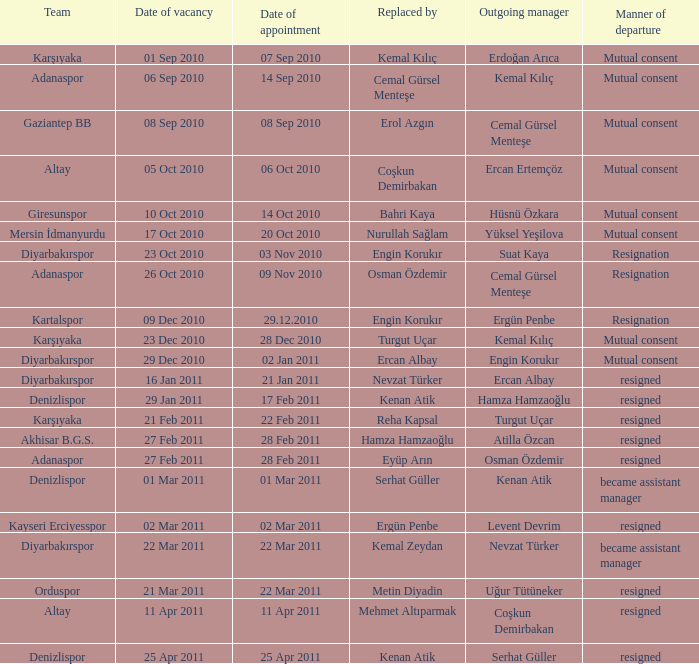When was the date of vacancy for the manager of Kartalspor?  09 Dec 2010. Write the full table. {'header': ['Team', 'Date of vacancy', 'Date of appointment', 'Replaced by', 'Outgoing manager', 'Manner of departure'], 'rows': [['Karşıyaka', '01 Sep 2010', '07 Sep 2010', 'Kemal Kılıç', 'Erdoğan Arıca', 'Mutual consent'], ['Adanaspor', '06 Sep 2010', '14 Sep 2010', 'Cemal Gürsel Menteşe', 'Kemal Kılıç', 'Mutual consent'], ['Gaziantep BB', '08 Sep 2010', '08 Sep 2010', 'Erol Azgın', 'Cemal Gürsel Menteşe', 'Mutual consent'], ['Altay', '05 Oct 2010', '06 Oct 2010', 'Coşkun Demirbakan', 'Ercan Ertemçöz', 'Mutual consent'], ['Giresunspor', '10 Oct 2010', '14 Oct 2010', 'Bahri Kaya', 'Hüsnü Özkara', 'Mutual consent'], ['Mersin İdmanyurdu', '17 Oct 2010', '20 Oct 2010', 'Nurullah Sağlam', 'Yüksel Yeşilova', 'Mutual consent'], ['Diyarbakırspor', '23 Oct 2010', '03 Nov 2010', 'Engin Korukır', 'Suat Kaya', 'Resignation'], ['Adanaspor', '26 Oct 2010', '09 Nov 2010', 'Osman Özdemir', 'Cemal Gürsel Menteşe', 'Resignation'], ['Kartalspor', '09 Dec 2010', '29.12.2010', 'Engin Korukır', 'Ergün Penbe', 'Resignation'], ['Karşıyaka', '23 Dec 2010', '28 Dec 2010', 'Turgut Uçar', 'Kemal Kılıç', 'Mutual consent'], ['Diyarbakırspor', '29 Dec 2010', '02 Jan 2011', 'Ercan Albay', 'Engin Korukır', 'Mutual consent'], ['Diyarbakırspor', '16 Jan 2011', '21 Jan 2011', 'Nevzat Türker', 'Ercan Albay', 'resigned'], ['Denizlispor', '29 Jan 2011', '17 Feb 2011', 'Kenan Atik', 'Hamza Hamzaoğlu', 'resigned'], ['Karşıyaka', '21 Feb 2011', '22 Feb 2011', 'Reha Kapsal', 'Turgut Uçar', 'resigned'], ['Akhisar B.G.S.', '27 Feb 2011', '28 Feb 2011', 'Hamza Hamzaoğlu', 'Atilla Özcan', 'resigned'], ['Adanaspor', '27 Feb 2011', '28 Feb 2011', 'Eyüp Arın', 'Osman Özdemir', 'resigned'], ['Denizlispor', '01 Mar 2011', '01 Mar 2011', 'Serhat Güller', 'Kenan Atik', 'became assistant manager'], ['Kayseri Erciyesspor', '02 Mar 2011', '02 Mar 2011', 'Ergün Penbe', 'Levent Devrim', 'resigned'], ['Diyarbakırspor', '22 Mar 2011', '22 Mar 2011', 'Kemal Zeydan', 'Nevzat Türker', 'became assistant manager'], ['Orduspor', '21 Mar 2011', '22 Mar 2011', 'Metin Diyadin', 'Uğur Tütüneker', 'resigned'], ['Altay', '11 Apr 2011', '11 Apr 2011', 'Mehmet Altıparmak', 'Coşkun Demirbakan', 'resigned'], ['Denizlispor', '25 Apr 2011', '25 Apr 2011', 'Kenan Atik', 'Serhat Güller', 'resigned']]} 